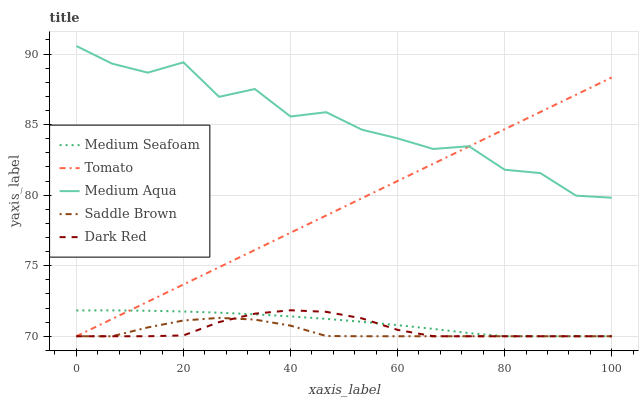Does Saddle Brown have the minimum area under the curve?
Answer yes or no. Yes. Does Medium Aqua have the maximum area under the curve?
Answer yes or no. Yes. Does Dark Red have the minimum area under the curve?
Answer yes or no. No. Does Dark Red have the maximum area under the curve?
Answer yes or no. No. Is Tomato the smoothest?
Answer yes or no. Yes. Is Medium Aqua the roughest?
Answer yes or no. Yes. Is Dark Red the smoothest?
Answer yes or no. No. Is Dark Red the roughest?
Answer yes or no. No. Does Tomato have the lowest value?
Answer yes or no. Yes. Does Medium Aqua have the lowest value?
Answer yes or no. No. Does Medium Aqua have the highest value?
Answer yes or no. Yes. Does Dark Red have the highest value?
Answer yes or no. No. Is Saddle Brown less than Medium Aqua?
Answer yes or no. Yes. Is Medium Aqua greater than Saddle Brown?
Answer yes or no. Yes. Does Tomato intersect Saddle Brown?
Answer yes or no. Yes. Is Tomato less than Saddle Brown?
Answer yes or no. No. Is Tomato greater than Saddle Brown?
Answer yes or no. No. Does Saddle Brown intersect Medium Aqua?
Answer yes or no. No. 